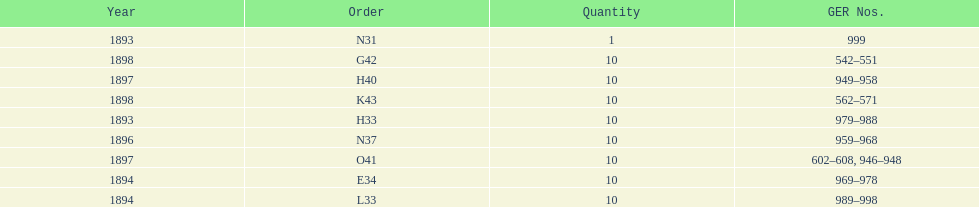What is the total number of locomotives made during this time? 81. 